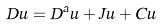Convert formula to latex. <formula><loc_0><loc_0><loc_500><loc_500>D u = D ^ { a } u + J u + C u</formula> 